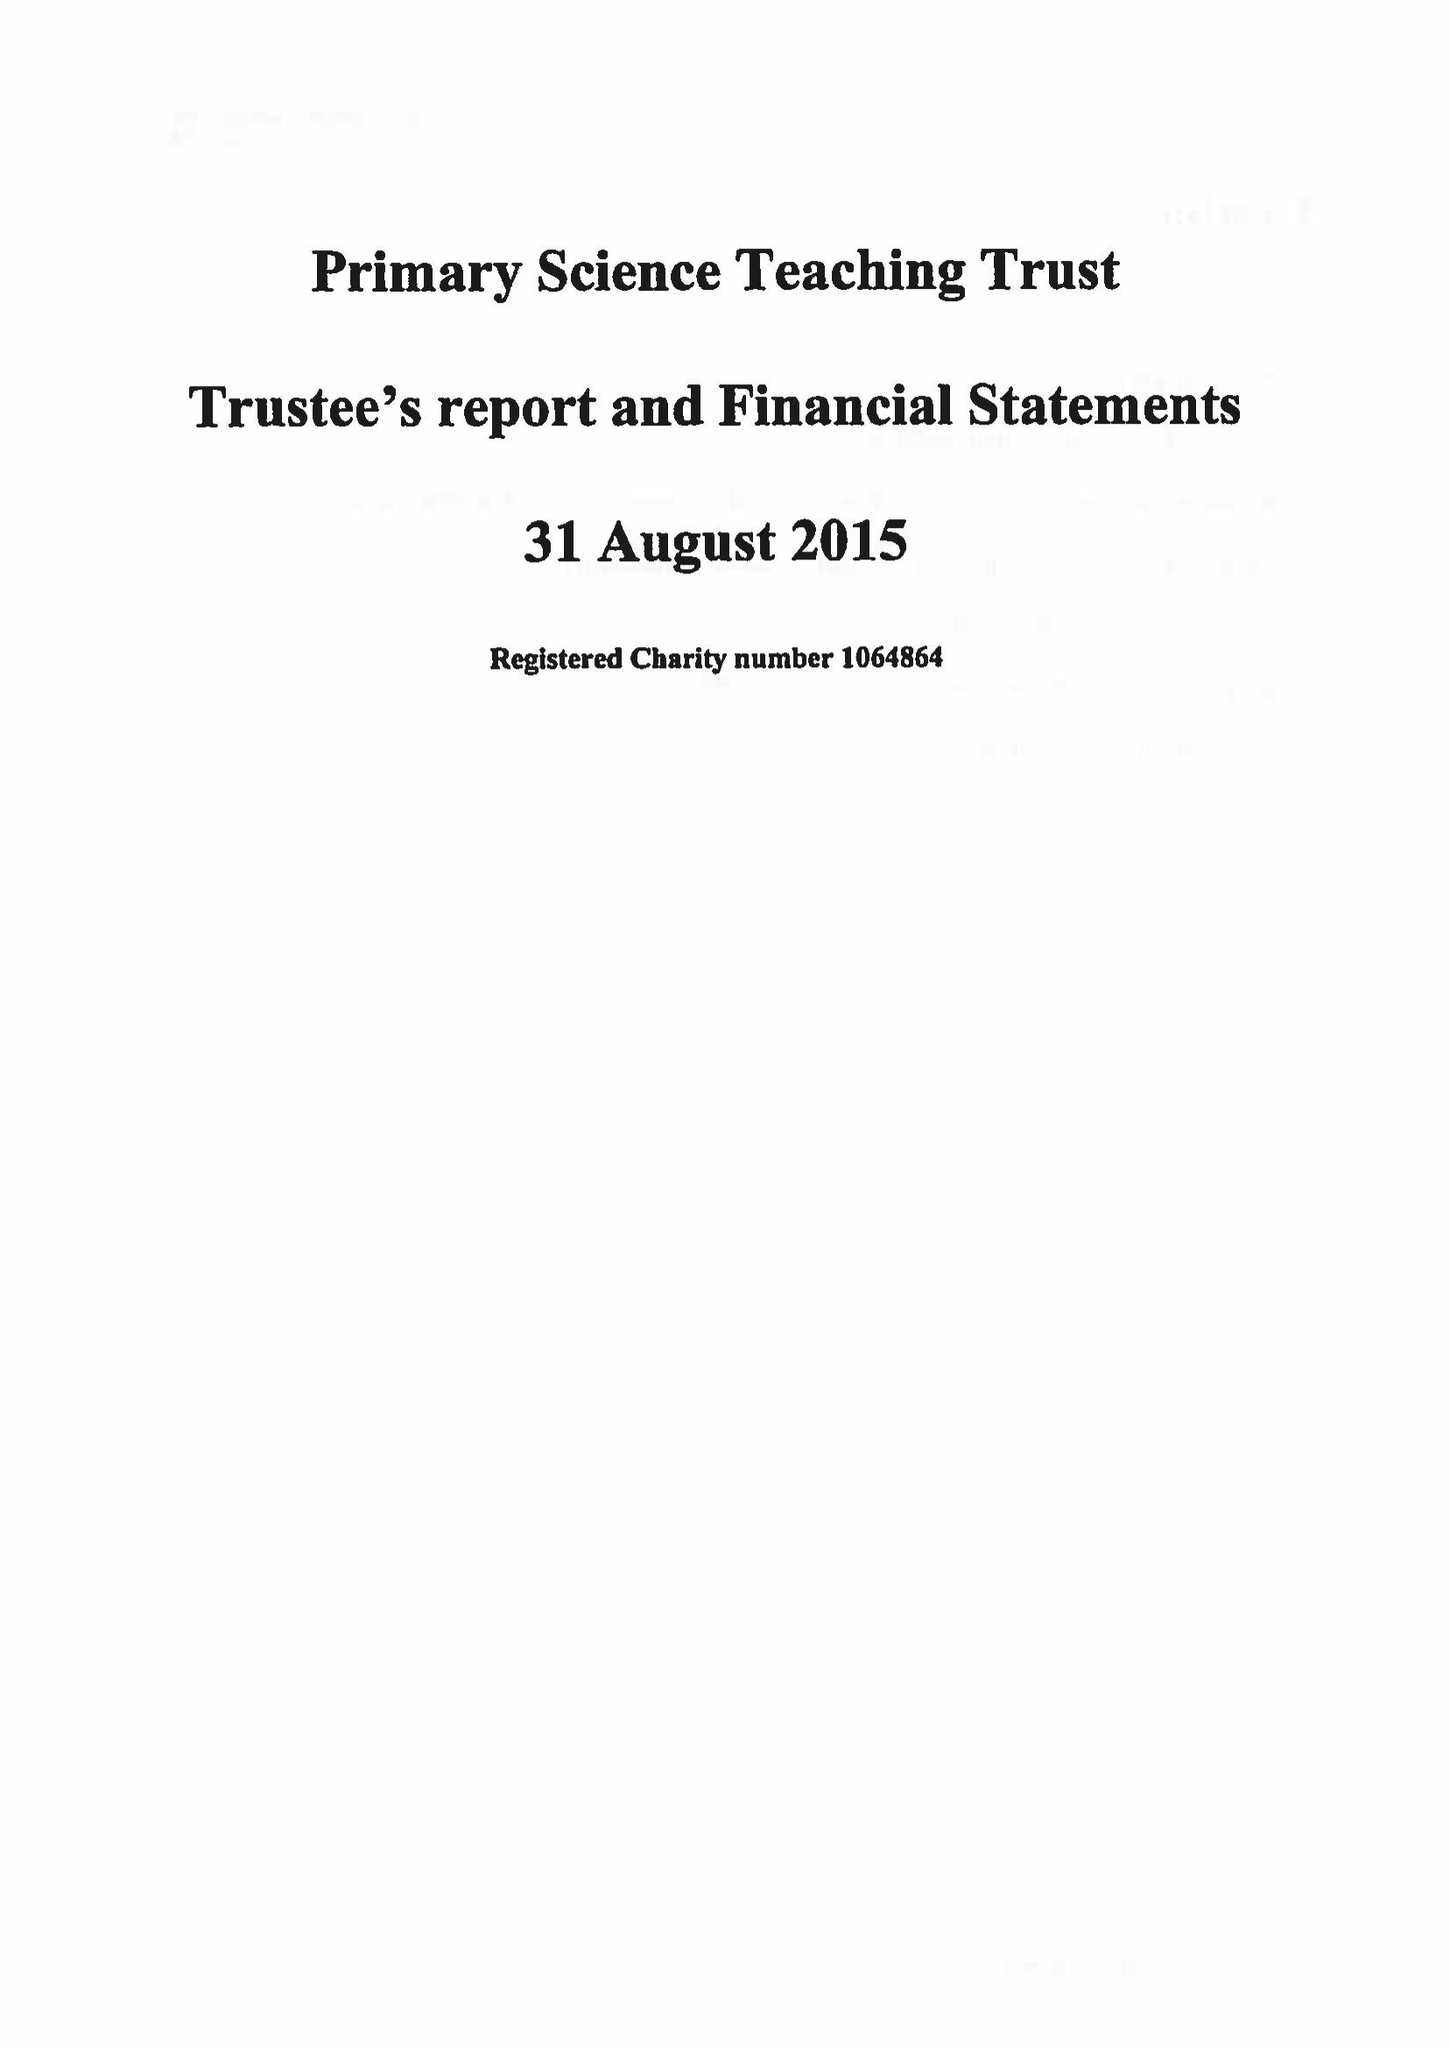What is the value for the address__street_line?
Answer the question using a single word or phrase. None 